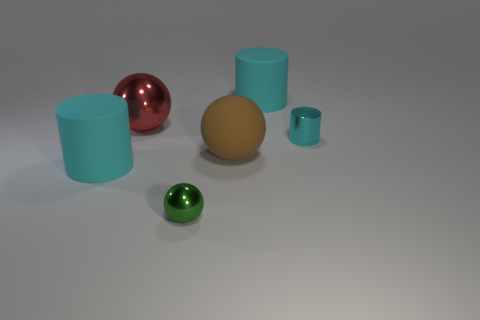How many spheres are either large cyan objects or red things?
Your answer should be very brief. 1. Are there any cyan metal things behind the large cyan cylinder right of the shiny object in front of the cyan metal cylinder?
Give a very brief answer. No. There is a large rubber object that is the same shape as the green shiny thing; what is its color?
Ensure brevity in your answer.  Brown. How many cyan things are small metallic spheres or metallic cylinders?
Give a very brief answer. 1. What is the material of the large red ball behind the small cyan metallic thing in front of the red sphere?
Give a very brief answer. Metal. Does the small cyan metallic object have the same shape as the red object?
Offer a terse response. No. What is the color of the other thing that is the same size as the green thing?
Offer a terse response. Cyan. Is there a small cube of the same color as the big metal object?
Make the answer very short. No. Are there any cyan cylinders?
Give a very brief answer. Yes. Is the large cyan cylinder behind the red metal sphere made of the same material as the big brown sphere?
Your answer should be very brief. Yes. 